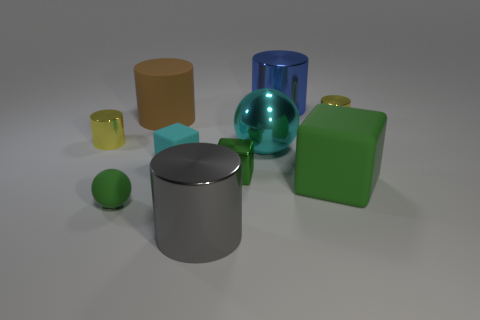Subtract all green blocks. How many blocks are left? 1 Subtract all cyan blocks. How many yellow cylinders are left? 2 Subtract all blue cylinders. How many cylinders are left? 4 Subtract 1 cubes. How many cubes are left? 2 Add 5 yellow cylinders. How many yellow cylinders are left? 7 Add 1 big matte objects. How many big matte objects exist? 3 Subtract 1 gray cylinders. How many objects are left? 9 Subtract all cubes. How many objects are left? 7 Subtract all gray cylinders. Subtract all cyan spheres. How many cylinders are left? 4 Subtract all red spheres. Subtract all large blue objects. How many objects are left? 9 